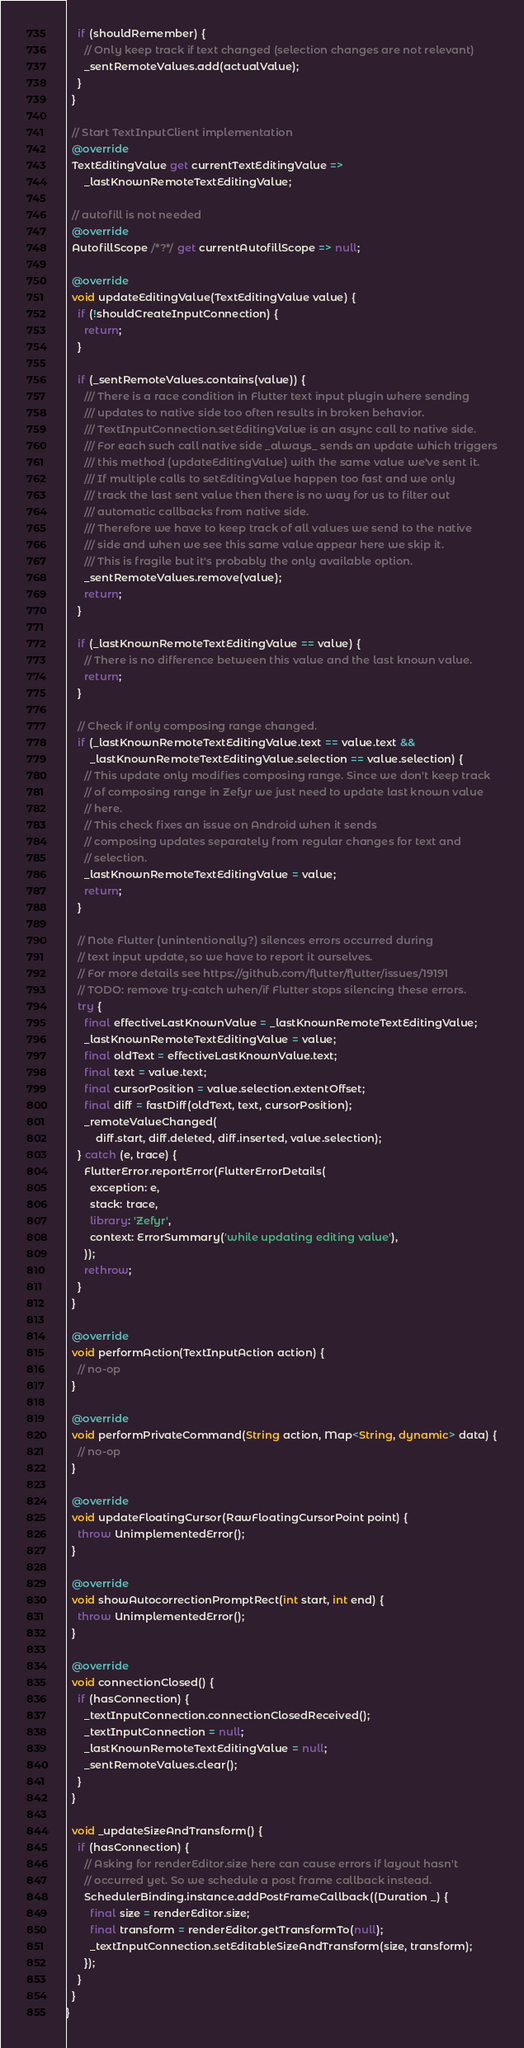<code> <loc_0><loc_0><loc_500><loc_500><_Dart_>    if (shouldRemember) {
      // Only keep track if text changed (selection changes are not relevant)
      _sentRemoteValues.add(actualValue);
    }
  }

  // Start TextInputClient implementation
  @override
  TextEditingValue get currentTextEditingValue =>
      _lastKnownRemoteTextEditingValue;

  // autofill is not needed
  @override
  AutofillScope /*?*/ get currentAutofillScope => null;

  @override
  void updateEditingValue(TextEditingValue value) {
    if (!shouldCreateInputConnection) {
      return;
    }

    if (_sentRemoteValues.contains(value)) {
      /// There is a race condition in Flutter text input plugin where sending
      /// updates to native side too often results in broken behavior.
      /// TextInputConnection.setEditingValue is an async call to native side.
      /// For each such call native side _always_ sends an update which triggers
      /// this method (updateEditingValue) with the same value we've sent it.
      /// If multiple calls to setEditingValue happen too fast and we only
      /// track the last sent value then there is no way for us to filter out
      /// automatic callbacks from native side.
      /// Therefore we have to keep track of all values we send to the native
      /// side and when we see this same value appear here we skip it.
      /// This is fragile but it's probably the only available option.
      _sentRemoteValues.remove(value);
      return;
    }

    if (_lastKnownRemoteTextEditingValue == value) {
      // There is no difference between this value and the last known value.
      return;
    }

    // Check if only composing range changed.
    if (_lastKnownRemoteTextEditingValue.text == value.text &&
        _lastKnownRemoteTextEditingValue.selection == value.selection) {
      // This update only modifies composing range. Since we don't keep track
      // of composing range in Zefyr we just need to update last known value
      // here.
      // This check fixes an issue on Android when it sends
      // composing updates separately from regular changes for text and
      // selection.
      _lastKnownRemoteTextEditingValue = value;
      return;
    }

    // Note Flutter (unintentionally?) silences errors occurred during
    // text input update, so we have to report it ourselves.
    // For more details see https://github.com/flutter/flutter/issues/19191
    // TODO: remove try-catch when/if Flutter stops silencing these errors.
    try {
      final effectiveLastKnownValue = _lastKnownRemoteTextEditingValue;
      _lastKnownRemoteTextEditingValue = value;
      final oldText = effectiveLastKnownValue.text;
      final text = value.text;
      final cursorPosition = value.selection.extentOffset;
      final diff = fastDiff(oldText, text, cursorPosition);
      _remoteValueChanged(
          diff.start, diff.deleted, diff.inserted, value.selection);
    } catch (e, trace) {
      FlutterError.reportError(FlutterErrorDetails(
        exception: e,
        stack: trace,
        library: 'Zefyr',
        context: ErrorSummary('while updating editing value'),
      ));
      rethrow;
    }
  }

  @override
  void performAction(TextInputAction action) {
    // no-op
  }

  @override
  void performPrivateCommand(String action, Map<String, dynamic> data) {
    // no-op
  }

  @override
  void updateFloatingCursor(RawFloatingCursorPoint point) {
    throw UnimplementedError();
  }

  @override
  void showAutocorrectionPromptRect(int start, int end) {
    throw UnimplementedError();
  }

  @override
  void connectionClosed() {
    if (hasConnection) {
      _textInputConnection.connectionClosedReceived();
      _textInputConnection = null;
      _lastKnownRemoteTextEditingValue = null;
      _sentRemoteValues.clear();
    }
  }

  void _updateSizeAndTransform() {
    if (hasConnection) {
      // Asking for renderEditor.size here can cause errors if layout hasn't
      // occurred yet. So we schedule a post frame callback instead.
      SchedulerBinding.instance.addPostFrameCallback((Duration _) {
        final size = renderEditor.size;
        final transform = renderEditor.getTransformTo(null);
        _textInputConnection.setEditableSizeAndTransform(size, transform);
      });
    }
  }
}
</code> 